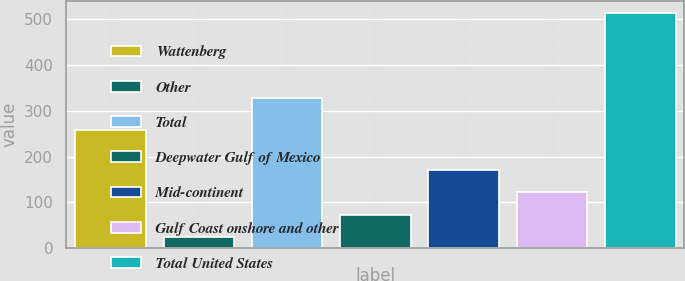Convert chart. <chart><loc_0><loc_0><loc_500><loc_500><bar_chart><fcel>Wattenberg<fcel>Other<fcel>Total<fcel>Deepwater Gulf of Mexico<fcel>Mid-continent<fcel>Gulf Coast onshore and other<fcel>Total United States<nl><fcel>258<fcel>24<fcel>329<fcel>73<fcel>171<fcel>122<fcel>514<nl></chart> 